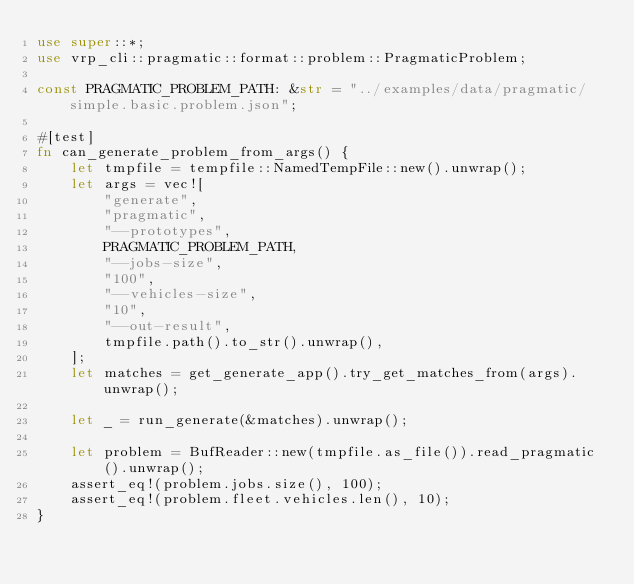Convert code to text. <code><loc_0><loc_0><loc_500><loc_500><_Rust_>use super::*;
use vrp_cli::pragmatic::format::problem::PragmaticProblem;

const PRAGMATIC_PROBLEM_PATH: &str = "../examples/data/pragmatic/simple.basic.problem.json";

#[test]
fn can_generate_problem_from_args() {
    let tmpfile = tempfile::NamedTempFile::new().unwrap();
    let args = vec![
        "generate",
        "pragmatic",
        "--prototypes",
        PRAGMATIC_PROBLEM_PATH,
        "--jobs-size",
        "100",
        "--vehicles-size",
        "10",
        "--out-result",
        tmpfile.path().to_str().unwrap(),
    ];
    let matches = get_generate_app().try_get_matches_from(args).unwrap();

    let _ = run_generate(&matches).unwrap();

    let problem = BufReader::new(tmpfile.as_file()).read_pragmatic().unwrap();
    assert_eq!(problem.jobs.size(), 100);
    assert_eq!(problem.fleet.vehicles.len(), 10);
}
</code> 